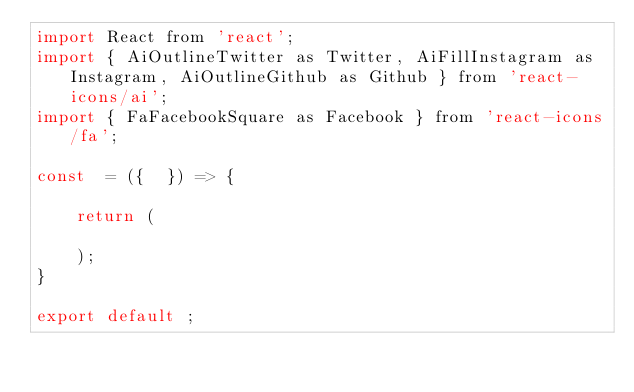<code> <loc_0><loc_0><loc_500><loc_500><_JavaScript_>import React from 'react';
import { AiOutlineTwitter as Twitter, AiFillInstagram as Instagram, AiOutlineGithub as Github } from 'react-icons/ai';
import { FaFacebookSquare as Facebook } from 'react-icons/fa';

const  = ({  }) => {

    return (

    );
}

export default ;</code> 